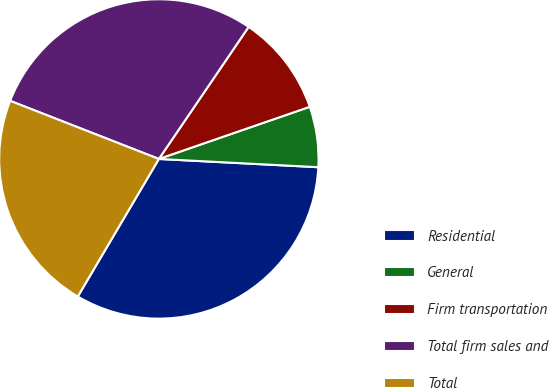Convert chart. <chart><loc_0><loc_0><loc_500><loc_500><pie_chart><fcel>Residential<fcel>General<fcel>Firm transportation<fcel>Total firm sales and<fcel>Total<nl><fcel>32.65%<fcel>6.12%<fcel>10.2%<fcel>28.57%<fcel>22.45%<nl></chart> 